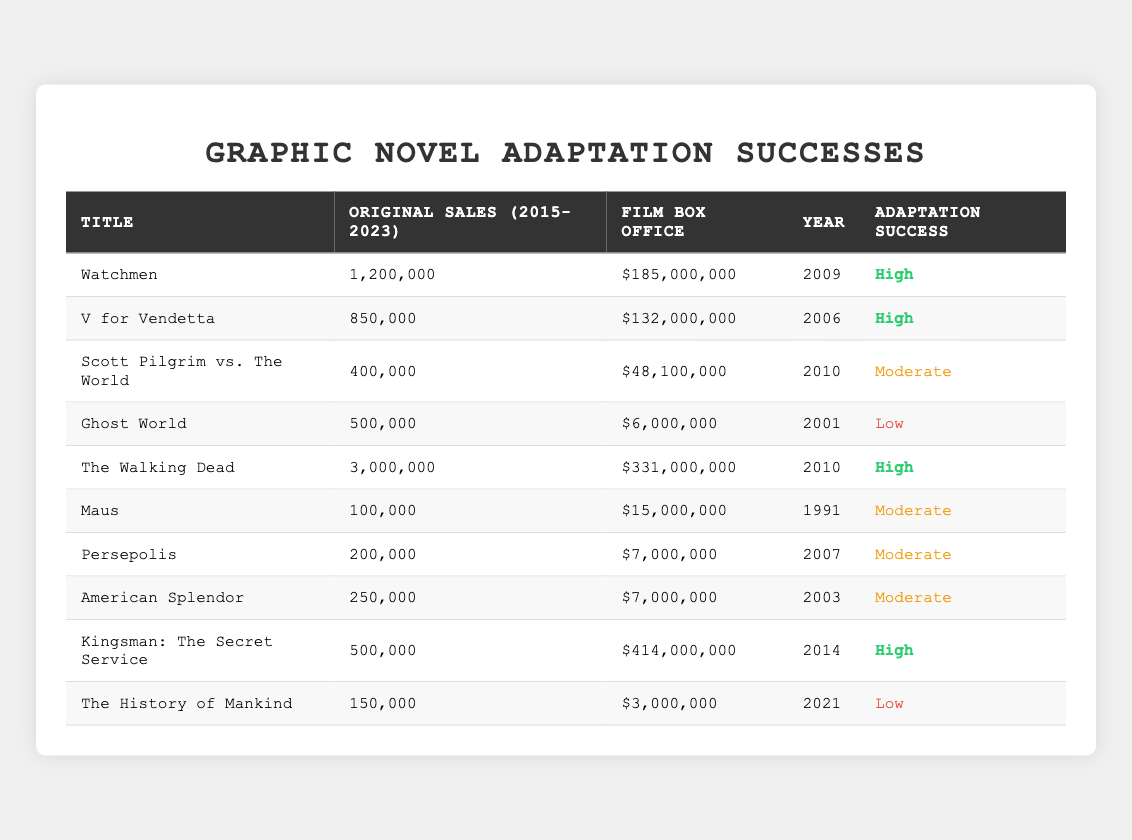What is the highest film box office revenue among the adaptations? The highest film box office revenue can be found in the "Film Box Office" column. Scanning the values, "Kingsman: The Secret Service" has the highest revenue of $414,000,000.
Answer: $414,000,000 Which graphic novel adaptation had the lowest original sales from 2015 to 2023? The lowest original sales can be found in the "Original Sales (2015-2023)" column. By checking this column, we see that "Maus" had the lowest sales with 100,000 units.
Answer: 100,000 How many adaptations have "High" success ratings? To find this, we can count the entries in the "Adaptation Success" column marked as "High." There are four entries: "Watchmen," "V for Vendetta," "The Walking Dead," and "Kingsman: The Secret Service."
Answer: 4 Is the film adaptation of "Scott Pilgrim vs. The World" considered a success? By checking the "Adaptation Success" column, we can see that "Scott Pilgrim vs. The World" has a "Moderate" success rating. Therefore, it is not considered a high success.
Answer: No What is the difference in box office revenue between "The Walking Dead" and "Ghost World"? To find the difference, we subtract the box office revenue of "Ghost World" ($6,000,000) from "The Walking Dead" ($331,000,000). So, $331,000,000 - $6,000,000 = $325,000,000.
Answer: $325,000,000 What is the average original sales for adaptations classified as "Moderate"? The original sales for the "Moderate" adaptations are: "Scott Pilgrim vs. The World" (400,000), "Maus" (100,000), "Persepolis" (200,000), and "American Splendor" (250,000). Sum = 400,000 + 100,000 + 200,000 + 250,000 = 950,000. There are 4 adaptations, so the average is 950,000 / 4 = 237,500.
Answer: 237,500 Do any adaptations have a film box office revenue lower than their original sales? We need to compare the "Film Box Office" to "Original Sales" for each adaptation. "Ghost World," with a film box office of $6,000,000 and original sales of 500,000, shows a lower box office value; thus, the answer is yes.
Answer: Yes List the adaptations that achieved a "High" success rate and have original sales above 1 million. We look at the adaptations with "High" success and check their original sales: "Watchmen" (1,200,000) and "The Walking Dead" (3,000,000) meet the criteria.
Answer: Watchmen, The Walking Dead How many adaptations have a film box office greater than $100 million? By reviewing the "Film Box Office" values, we find that "Watchmen," "V for Vendetta," "The Walking Dead," and "Kingsman: The Secret Service" all exceed $100 million. Thus, there are four adaptations.
Answer: 4 What percentage of the adaptations were classified as "Low" in terms of success? There are 10 adaptations in total and 2 are classified as "Low" ("Ghost World" and "The History of Mankind"). The percentage is (2/10) * 100 = 20%.
Answer: 20% 